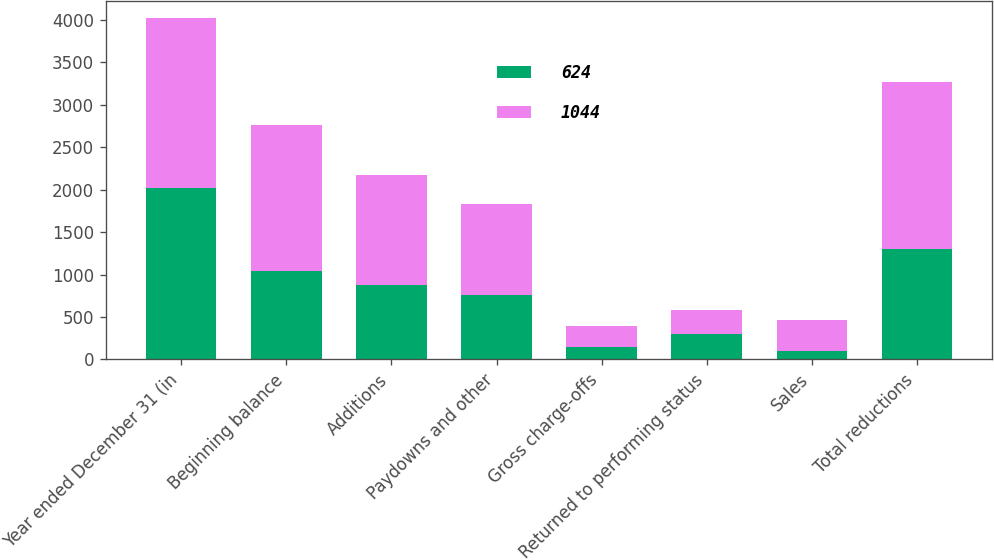Convert chart to OTSL. <chart><loc_0><loc_0><loc_500><loc_500><stacked_bar_chart><ecel><fcel>Year ended December 31 (in<fcel>Beginning balance<fcel>Additions<fcel>Paydowns and other<fcel>Gross charge-offs<fcel>Returned to performing status<fcel>Sales<fcel>Total reductions<nl><fcel>624<fcel>2014<fcel>1044<fcel>882<fcel>756<fcel>148<fcel>303<fcel>95<fcel>1302<nl><fcel>1044<fcel>2013<fcel>1717<fcel>1293<fcel>1075<fcel>241<fcel>279<fcel>371<fcel>1966<nl></chart> 